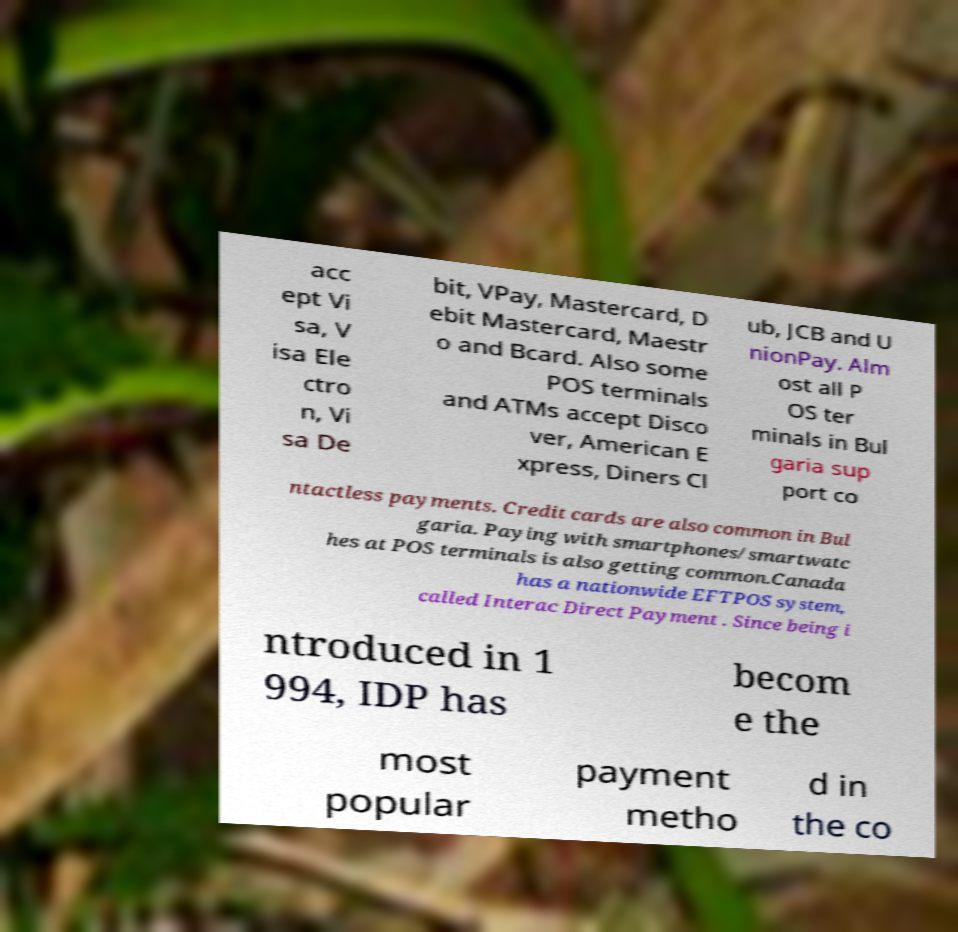I need the written content from this picture converted into text. Can you do that? acc ept Vi sa, V isa Ele ctro n, Vi sa De bit, VPay, Mastercard, D ebit Mastercard, Maestr o and Bcard. Also some POS terminals and ATMs accept Disco ver, American E xpress, Diners Cl ub, JCB and U nionPay. Alm ost all P OS ter minals in Bul garia sup port co ntactless payments. Credit cards are also common in Bul garia. Paying with smartphones/smartwatc hes at POS terminals is also getting common.Canada has a nationwide EFTPOS system, called Interac Direct Payment . Since being i ntroduced in 1 994, IDP has becom e the most popular payment metho d in the co 